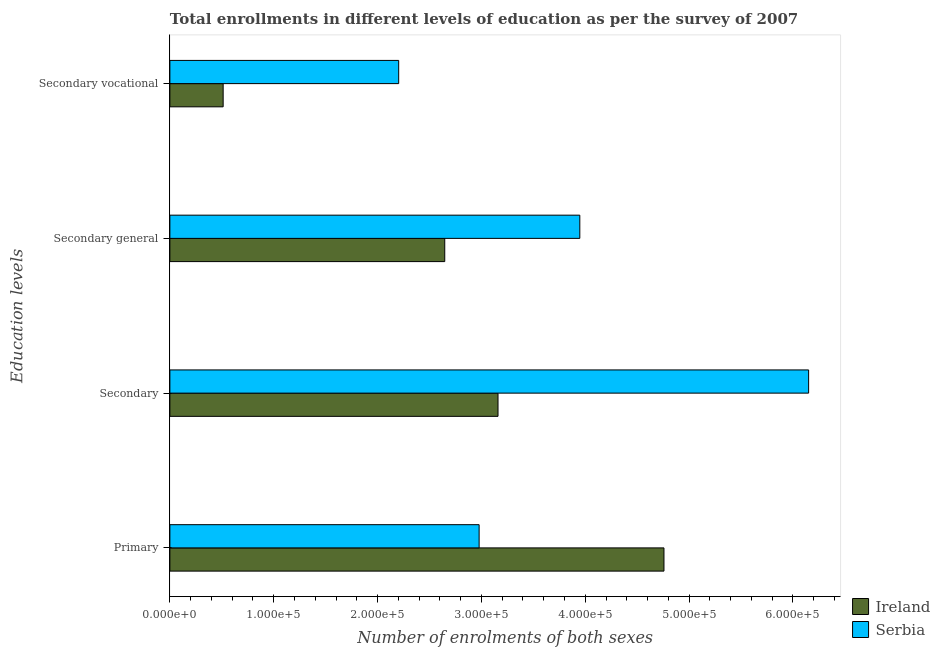How many different coloured bars are there?
Provide a succinct answer. 2. How many bars are there on the 1st tick from the top?
Your answer should be compact. 2. What is the label of the 3rd group of bars from the top?
Make the answer very short. Secondary. What is the number of enrolments in secondary education in Serbia?
Provide a succinct answer. 6.15e+05. Across all countries, what is the maximum number of enrolments in secondary vocational education?
Give a very brief answer. 2.20e+05. Across all countries, what is the minimum number of enrolments in secondary vocational education?
Offer a terse response. 5.13e+04. In which country was the number of enrolments in secondary education maximum?
Keep it short and to the point. Serbia. In which country was the number of enrolments in primary education minimum?
Ensure brevity in your answer.  Serbia. What is the total number of enrolments in secondary general education in the graph?
Provide a short and direct response. 6.59e+05. What is the difference between the number of enrolments in secondary education in Serbia and that in Ireland?
Offer a very short reply. 2.99e+05. What is the difference between the number of enrolments in secondary vocational education in Ireland and the number of enrolments in secondary education in Serbia?
Make the answer very short. -5.64e+05. What is the average number of enrolments in secondary general education per country?
Your answer should be compact. 3.30e+05. What is the difference between the number of enrolments in secondary general education and number of enrolments in secondary vocational education in Ireland?
Your answer should be very brief. 2.13e+05. In how many countries, is the number of enrolments in secondary general education greater than 400000 ?
Give a very brief answer. 0. What is the ratio of the number of enrolments in secondary general education in Serbia to that in Ireland?
Offer a very short reply. 1.49. Is the number of enrolments in secondary vocational education in Ireland less than that in Serbia?
Give a very brief answer. Yes. What is the difference between the highest and the second highest number of enrolments in primary education?
Provide a short and direct response. 1.78e+05. What is the difference between the highest and the lowest number of enrolments in secondary vocational education?
Offer a terse response. 1.69e+05. In how many countries, is the number of enrolments in primary education greater than the average number of enrolments in primary education taken over all countries?
Your answer should be compact. 1. What does the 1st bar from the top in Secondary general represents?
Offer a terse response. Serbia. What does the 2nd bar from the bottom in Secondary represents?
Ensure brevity in your answer.  Serbia. Is it the case that in every country, the sum of the number of enrolments in primary education and number of enrolments in secondary education is greater than the number of enrolments in secondary general education?
Provide a short and direct response. Yes. How many bars are there?
Your answer should be compact. 8. How many countries are there in the graph?
Ensure brevity in your answer.  2. What is the difference between two consecutive major ticks on the X-axis?
Offer a very short reply. 1.00e+05. Are the values on the major ticks of X-axis written in scientific E-notation?
Offer a very short reply. Yes. Does the graph contain grids?
Keep it short and to the point. No. Where does the legend appear in the graph?
Offer a very short reply. Bottom right. How many legend labels are there?
Your answer should be compact. 2. What is the title of the graph?
Your answer should be very brief. Total enrollments in different levels of education as per the survey of 2007. What is the label or title of the X-axis?
Your answer should be very brief. Number of enrolments of both sexes. What is the label or title of the Y-axis?
Make the answer very short. Education levels. What is the Number of enrolments of both sexes in Ireland in Primary?
Offer a very short reply. 4.76e+05. What is the Number of enrolments of both sexes in Serbia in Primary?
Keep it short and to the point. 2.98e+05. What is the Number of enrolments of both sexes of Ireland in Secondary?
Provide a succinct answer. 3.16e+05. What is the Number of enrolments of both sexes in Serbia in Secondary?
Your answer should be compact. 6.15e+05. What is the Number of enrolments of both sexes in Ireland in Secondary general?
Offer a terse response. 2.65e+05. What is the Number of enrolments of both sexes in Serbia in Secondary general?
Offer a very short reply. 3.95e+05. What is the Number of enrolments of both sexes in Ireland in Secondary vocational?
Your answer should be very brief. 5.13e+04. What is the Number of enrolments of both sexes in Serbia in Secondary vocational?
Your answer should be compact. 2.20e+05. Across all Education levels, what is the maximum Number of enrolments of both sexes of Ireland?
Provide a short and direct response. 4.76e+05. Across all Education levels, what is the maximum Number of enrolments of both sexes in Serbia?
Provide a succinct answer. 6.15e+05. Across all Education levels, what is the minimum Number of enrolments of both sexes in Ireland?
Provide a succinct answer. 5.13e+04. Across all Education levels, what is the minimum Number of enrolments of both sexes in Serbia?
Provide a short and direct response. 2.20e+05. What is the total Number of enrolments of both sexes in Ireland in the graph?
Offer a terse response. 1.11e+06. What is the total Number of enrolments of both sexes in Serbia in the graph?
Provide a short and direct response. 1.53e+06. What is the difference between the Number of enrolments of both sexes of Ireland in Primary and that in Secondary?
Make the answer very short. 1.60e+05. What is the difference between the Number of enrolments of both sexes in Serbia in Primary and that in Secondary?
Make the answer very short. -3.17e+05. What is the difference between the Number of enrolments of both sexes of Ireland in Primary and that in Secondary general?
Give a very brief answer. 2.11e+05. What is the difference between the Number of enrolments of both sexes of Serbia in Primary and that in Secondary general?
Offer a very short reply. -9.70e+04. What is the difference between the Number of enrolments of both sexes in Ireland in Primary and that in Secondary vocational?
Provide a succinct answer. 4.25e+05. What is the difference between the Number of enrolments of both sexes of Serbia in Primary and that in Secondary vocational?
Provide a succinct answer. 7.75e+04. What is the difference between the Number of enrolments of both sexes in Ireland in Secondary and that in Secondary general?
Offer a very short reply. 5.13e+04. What is the difference between the Number of enrolments of both sexes in Serbia in Secondary and that in Secondary general?
Ensure brevity in your answer.  2.20e+05. What is the difference between the Number of enrolments of both sexes of Ireland in Secondary and that in Secondary vocational?
Provide a succinct answer. 2.65e+05. What is the difference between the Number of enrolments of both sexes in Serbia in Secondary and that in Secondary vocational?
Your response must be concise. 3.95e+05. What is the difference between the Number of enrolments of both sexes of Ireland in Secondary general and that in Secondary vocational?
Offer a very short reply. 2.13e+05. What is the difference between the Number of enrolments of both sexes in Serbia in Secondary general and that in Secondary vocational?
Provide a short and direct response. 1.74e+05. What is the difference between the Number of enrolments of both sexes in Ireland in Primary and the Number of enrolments of both sexes in Serbia in Secondary?
Keep it short and to the point. -1.39e+05. What is the difference between the Number of enrolments of both sexes in Ireland in Primary and the Number of enrolments of both sexes in Serbia in Secondary general?
Your response must be concise. 8.11e+04. What is the difference between the Number of enrolments of both sexes of Ireland in Primary and the Number of enrolments of both sexes of Serbia in Secondary vocational?
Provide a succinct answer. 2.55e+05. What is the difference between the Number of enrolments of both sexes in Ireland in Secondary and the Number of enrolments of both sexes in Serbia in Secondary general?
Provide a succinct answer. -7.88e+04. What is the difference between the Number of enrolments of both sexes of Ireland in Secondary and the Number of enrolments of both sexes of Serbia in Secondary vocational?
Your answer should be very brief. 9.57e+04. What is the difference between the Number of enrolments of both sexes in Ireland in Secondary general and the Number of enrolments of both sexes in Serbia in Secondary vocational?
Keep it short and to the point. 4.44e+04. What is the average Number of enrolments of both sexes of Ireland per Education levels?
Provide a succinct answer. 2.77e+05. What is the average Number of enrolments of both sexes in Serbia per Education levels?
Offer a very short reply. 3.82e+05. What is the difference between the Number of enrolments of both sexes of Ireland and Number of enrolments of both sexes of Serbia in Primary?
Offer a terse response. 1.78e+05. What is the difference between the Number of enrolments of both sexes in Ireland and Number of enrolments of both sexes in Serbia in Secondary?
Give a very brief answer. -2.99e+05. What is the difference between the Number of enrolments of both sexes of Ireland and Number of enrolments of both sexes of Serbia in Secondary general?
Make the answer very short. -1.30e+05. What is the difference between the Number of enrolments of both sexes in Ireland and Number of enrolments of both sexes in Serbia in Secondary vocational?
Your answer should be compact. -1.69e+05. What is the ratio of the Number of enrolments of both sexes of Ireland in Primary to that in Secondary?
Your answer should be compact. 1.51. What is the ratio of the Number of enrolments of both sexes of Serbia in Primary to that in Secondary?
Provide a short and direct response. 0.48. What is the ratio of the Number of enrolments of both sexes in Ireland in Primary to that in Secondary general?
Offer a very short reply. 1.8. What is the ratio of the Number of enrolments of both sexes of Serbia in Primary to that in Secondary general?
Your answer should be very brief. 0.75. What is the ratio of the Number of enrolments of both sexes of Ireland in Primary to that in Secondary vocational?
Keep it short and to the point. 9.27. What is the ratio of the Number of enrolments of both sexes in Serbia in Primary to that in Secondary vocational?
Keep it short and to the point. 1.35. What is the ratio of the Number of enrolments of both sexes in Ireland in Secondary to that in Secondary general?
Provide a short and direct response. 1.19. What is the ratio of the Number of enrolments of both sexes of Serbia in Secondary to that in Secondary general?
Offer a very short reply. 1.56. What is the ratio of the Number of enrolments of both sexes in Ireland in Secondary to that in Secondary vocational?
Ensure brevity in your answer.  6.16. What is the ratio of the Number of enrolments of both sexes in Serbia in Secondary to that in Secondary vocational?
Your answer should be very brief. 2.79. What is the ratio of the Number of enrolments of both sexes in Ireland in Secondary general to that in Secondary vocational?
Your answer should be compact. 5.16. What is the ratio of the Number of enrolments of both sexes in Serbia in Secondary general to that in Secondary vocational?
Your response must be concise. 1.79. What is the difference between the highest and the second highest Number of enrolments of both sexes in Ireland?
Keep it short and to the point. 1.60e+05. What is the difference between the highest and the second highest Number of enrolments of both sexes in Serbia?
Provide a short and direct response. 2.20e+05. What is the difference between the highest and the lowest Number of enrolments of both sexes of Ireland?
Your answer should be compact. 4.25e+05. What is the difference between the highest and the lowest Number of enrolments of both sexes in Serbia?
Offer a very short reply. 3.95e+05. 